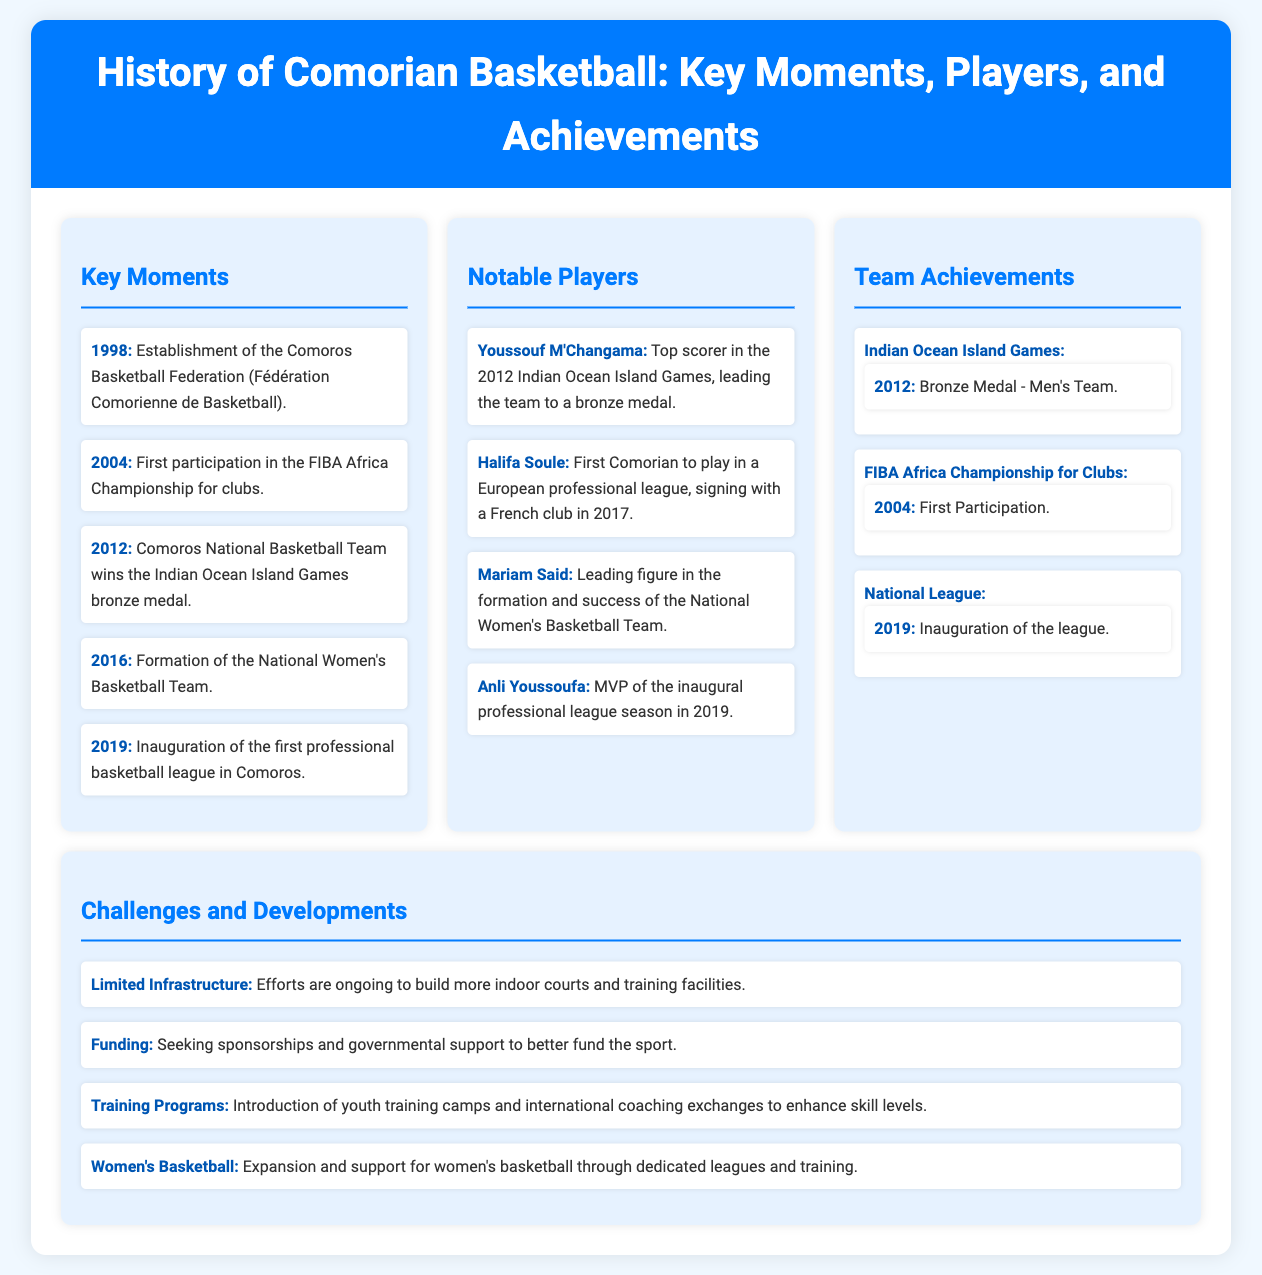What year was the Comoros Basketball Federation established? The establishment year of the Comoros Basketball Federation is explicitly mentioned in the document under Key Moments.
Answer: 1998 Who was the top scorer in the 2012 Indian Ocean Island Games? The document identifies Youssouf M'Changama as the top scorer during the 2012 Indian Ocean Island Games in the Notable Players section.
Answer: Youssouf M'Changama What medal did the Comoros National Basketball Team win in 2012? The document states that the team won a bronze medal at the Indian Ocean Island Games in the Team Achievements section.
Answer: Bronze Medal What significant event took place in 2019 related to basketball in Comoros? The document details the inauguration of the first professional basketball league in Comoros under Key Moments.
Answer: Inauguration of the first professional basketball league What challenges does Comorian basketball currently face? The document lists challenges in the Challenges and Developments section, emphasizing limited infrastructure and funding issues.
Answer: Limited Infrastructure Which notable female player helped establish the National Women's Basketball Team? The document credits Mariam Said as a leading figure in the formation of the National Women's Basketball Team in the Notable Players section.
Answer: Mariam Said How many years passed between the establishment of the Comoros Basketball Federation and the first participation in the FIBA Africa Championship? The years 1998 (establishment) and 2004 (first participation) can be compared to calculate the difference.
Answer: 6 years What measure is being taken to improve skill levels in Comorian basketball? The document mentions the introduction of youth training camps and international coaching exchanges in the Challenges and Developments section as a measure for improvement.
Answer: Training Programs 